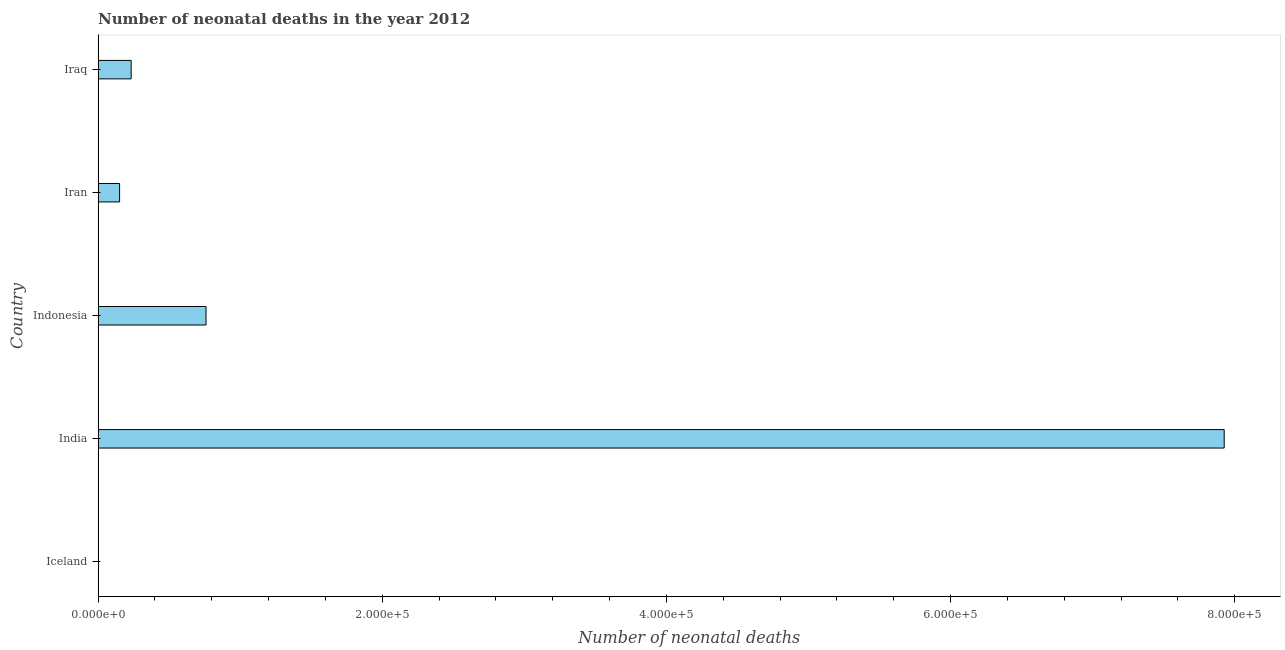Does the graph contain grids?
Ensure brevity in your answer.  No. What is the title of the graph?
Your answer should be compact. Number of neonatal deaths in the year 2012. What is the label or title of the X-axis?
Your response must be concise. Number of neonatal deaths. What is the label or title of the Y-axis?
Give a very brief answer. Country. What is the number of neonatal deaths in Iran?
Provide a succinct answer. 1.51e+04. Across all countries, what is the maximum number of neonatal deaths?
Your answer should be compact. 7.93e+05. Across all countries, what is the minimum number of neonatal deaths?
Ensure brevity in your answer.  5. What is the sum of the number of neonatal deaths?
Provide a short and direct response. 9.07e+05. What is the difference between the number of neonatal deaths in Iceland and India?
Your answer should be very brief. -7.93e+05. What is the average number of neonatal deaths per country?
Make the answer very short. 1.81e+05. What is the median number of neonatal deaths?
Offer a terse response. 2.33e+04. In how many countries, is the number of neonatal deaths greater than 520000 ?
Offer a very short reply. 1. What is the ratio of the number of neonatal deaths in India to that in Iraq?
Provide a succinct answer. 34.08. Is the difference between the number of neonatal deaths in Iceland and Iran greater than the difference between any two countries?
Provide a succinct answer. No. What is the difference between the highest and the second highest number of neonatal deaths?
Make the answer very short. 7.17e+05. Is the sum of the number of neonatal deaths in Iceland and Iran greater than the maximum number of neonatal deaths across all countries?
Provide a short and direct response. No. What is the difference between the highest and the lowest number of neonatal deaths?
Keep it short and to the point. 7.93e+05. How many bars are there?
Offer a very short reply. 5. How many countries are there in the graph?
Offer a terse response. 5. Are the values on the major ticks of X-axis written in scientific E-notation?
Provide a short and direct response. Yes. What is the Number of neonatal deaths in Iceland?
Give a very brief answer. 5. What is the Number of neonatal deaths of India?
Your answer should be very brief. 7.93e+05. What is the Number of neonatal deaths in Indonesia?
Your answer should be very brief. 7.60e+04. What is the Number of neonatal deaths of Iran?
Offer a very short reply. 1.51e+04. What is the Number of neonatal deaths in Iraq?
Offer a terse response. 2.33e+04. What is the difference between the Number of neonatal deaths in Iceland and India?
Make the answer very short. -7.93e+05. What is the difference between the Number of neonatal deaths in Iceland and Indonesia?
Offer a very short reply. -7.60e+04. What is the difference between the Number of neonatal deaths in Iceland and Iran?
Provide a succinct answer. -1.51e+04. What is the difference between the Number of neonatal deaths in Iceland and Iraq?
Provide a succinct answer. -2.32e+04. What is the difference between the Number of neonatal deaths in India and Indonesia?
Your answer should be very brief. 7.17e+05. What is the difference between the Number of neonatal deaths in India and Iran?
Provide a succinct answer. 7.77e+05. What is the difference between the Number of neonatal deaths in India and Iraq?
Ensure brevity in your answer.  7.69e+05. What is the difference between the Number of neonatal deaths in Indonesia and Iran?
Your answer should be compact. 6.08e+04. What is the difference between the Number of neonatal deaths in Indonesia and Iraq?
Keep it short and to the point. 5.27e+04. What is the difference between the Number of neonatal deaths in Iran and Iraq?
Offer a terse response. -8140. What is the ratio of the Number of neonatal deaths in Iceland to that in India?
Ensure brevity in your answer.  0. What is the ratio of the Number of neonatal deaths in Iceland to that in Iran?
Offer a very short reply. 0. What is the ratio of the Number of neonatal deaths in Iceland to that in Iraq?
Offer a very short reply. 0. What is the ratio of the Number of neonatal deaths in India to that in Indonesia?
Provide a short and direct response. 10.44. What is the ratio of the Number of neonatal deaths in India to that in Iran?
Provide a short and direct response. 52.44. What is the ratio of the Number of neonatal deaths in India to that in Iraq?
Your answer should be compact. 34.08. What is the ratio of the Number of neonatal deaths in Indonesia to that in Iran?
Offer a very short reply. 5.03. What is the ratio of the Number of neonatal deaths in Indonesia to that in Iraq?
Keep it short and to the point. 3.27. What is the ratio of the Number of neonatal deaths in Iran to that in Iraq?
Offer a very short reply. 0.65. 